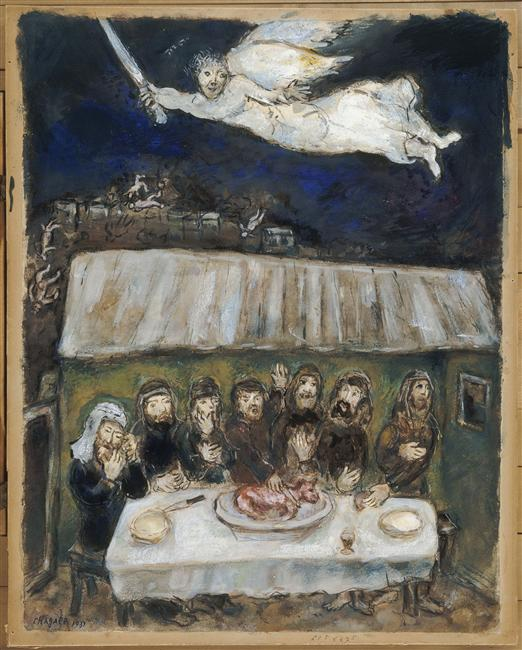If this image were part of a broader narrative, what might the previous scene depict? The previous scene could depict the villagers preparing for the ritual, gathering around a bonfire under the darkening sky. Elders might be seen teaching the younger ones the importance of the ceremony, while others prepare the sacred meat, an offering chosen through generations. The scene is filled with anticipation and reverence, capturing their hopes and fears as they prepare to invoke the divine presence. 